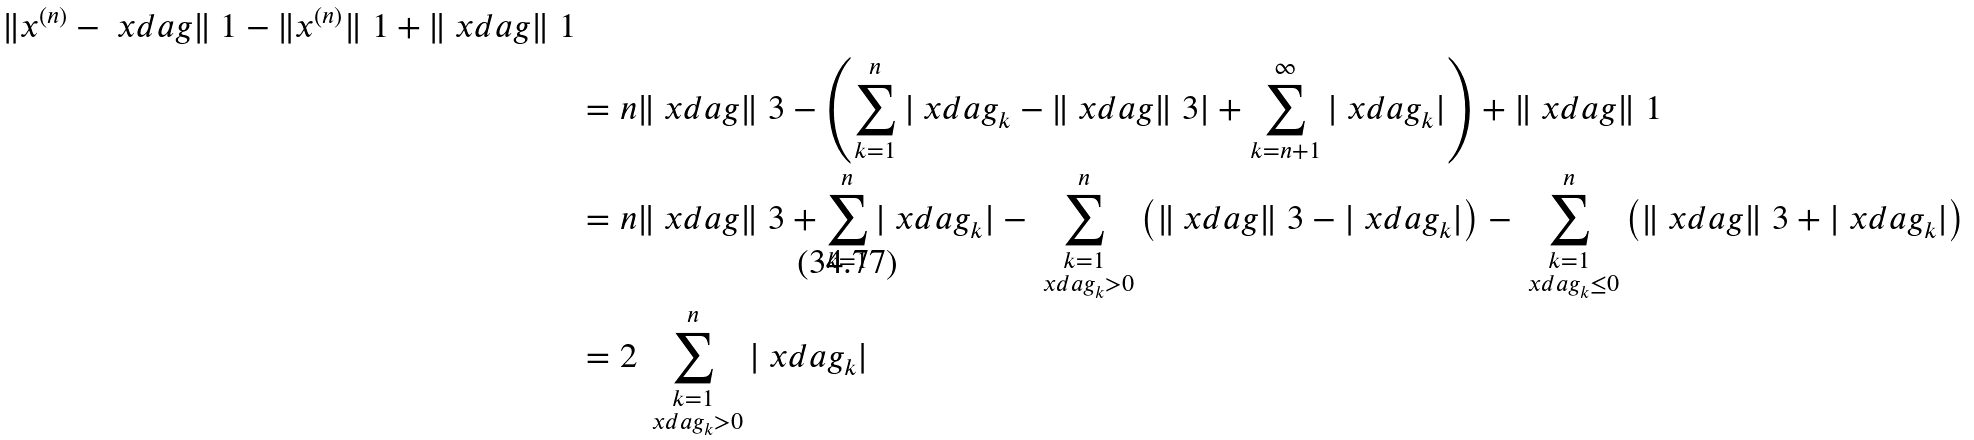Convert formula to latex. <formula><loc_0><loc_0><loc_500><loc_500>{ \| x ^ { ( n ) } - \ x d a g \| _ { \ } 1 - \| x ^ { ( n ) } \| _ { \ } 1 + \| \ x d a g \| _ { \ } 1 } \\ & = n \| \ x d a g \| _ { \ } 3 - \left ( \sum _ { k = 1 } ^ { n } | \ x d a g _ { k } - \| \ x d a g \| _ { \ } 3 | + \sum _ { k = n + 1 } ^ { \infty } | \ x d a g _ { k } | \right ) + \| \ x d a g \| _ { \ } 1 \\ & = n \| \ x d a g \| _ { \ } 3 + \sum _ { k = 1 } ^ { n } | \ x d a g _ { k } | - \sum _ { \substack { k = 1 \\ \ x d a g _ { k } > 0 } } ^ { n } \left ( \| \ x d a g \| _ { \ } 3 - | \ x d a g _ { k } | \right ) - \sum _ { \substack { k = 1 \\ \ x d a g _ { k } \leq 0 } } ^ { n } \left ( \| \ x d a g \| _ { \ } 3 + | \ x d a g _ { k } | \right ) \\ & = 2 \sum _ { \substack { k = 1 \\ \ x d a g _ { k } > 0 } } ^ { n } | \ x d a g _ { k } |</formula> 